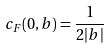<formula> <loc_0><loc_0><loc_500><loc_500>c _ { F } ( 0 , b ) = \frac { 1 } { 2 | b | }</formula> 